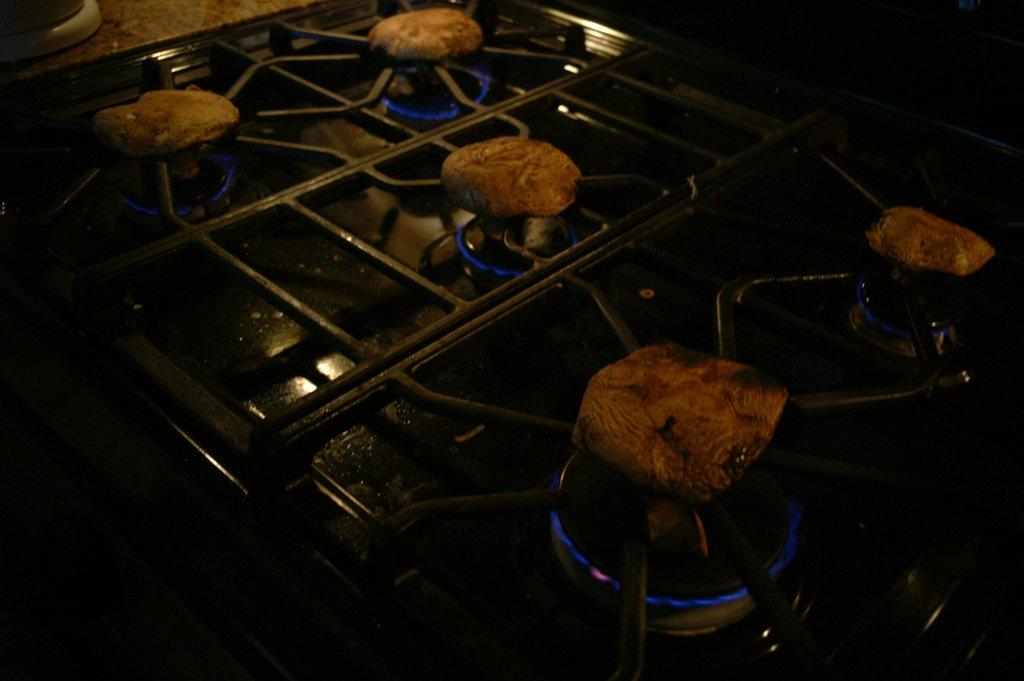What type of cooking appliance is present in the image? There is a stove in the image. What is happening with the stove in the image? The stove has flames. What feature is present on the stove? There are grills on the stove. What is being cooked on the stove? Food items are on the grills. What type of trouble is the stove experiencing in the image? There is no indication of trouble with the stove in the image; it appears to be functioning normally with flames and food items on the grills. 